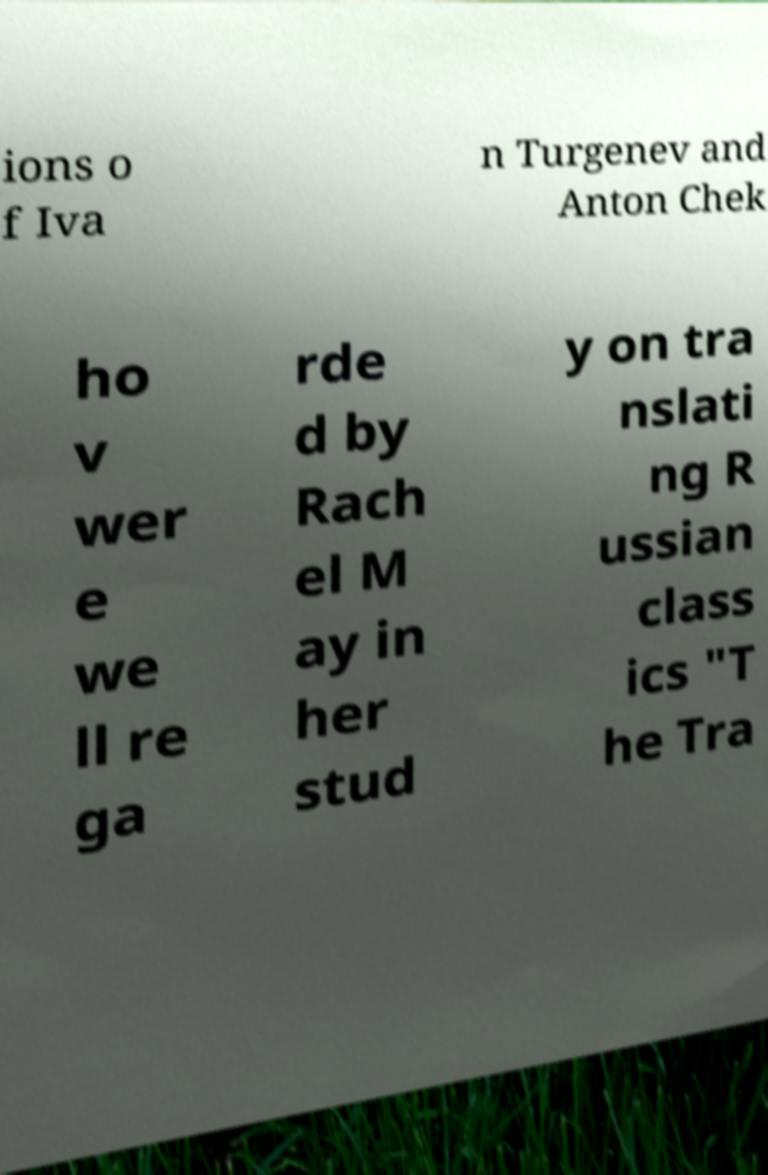Can you accurately transcribe the text from the provided image for me? ions o f Iva n Turgenev and Anton Chek ho v wer e we ll re ga rde d by Rach el M ay in her stud y on tra nslati ng R ussian class ics "T he Tra 